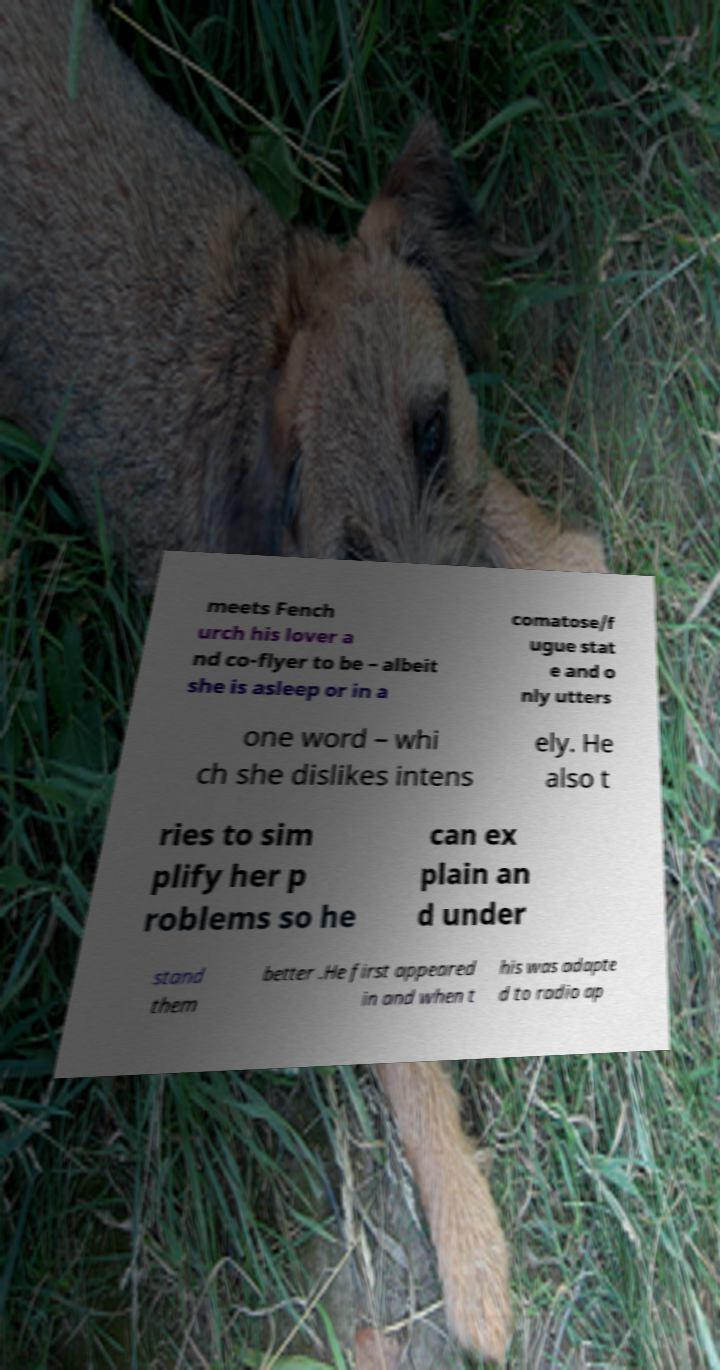Can you read and provide the text displayed in the image?This photo seems to have some interesting text. Can you extract and type it out for me? meets Fench urch his lover a nd co-flyer to be – albeit she is asleep or in a comatose/f ugue stat e and o nly utters one word – whi ch she dislikes intens ely. He also t ries to sim plify her p roblems so he can ex plain an d under stand them better .He first appeared in and when t his was adapte d to radio ap 